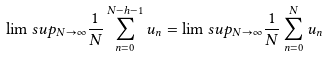<formula> <loc_0><loc_0><loc_500><loc_500>\lim s u p _ { N \to \infty } \frac { 1 } { N } \sum _ { n = 0 } ^ { N - h - 1 } u _ { n } = \lim s u p _ { N \to \infty } \frac { 1 } { N } \sum _ { n = 0 } ^ { N } u _ { n }</formula> 